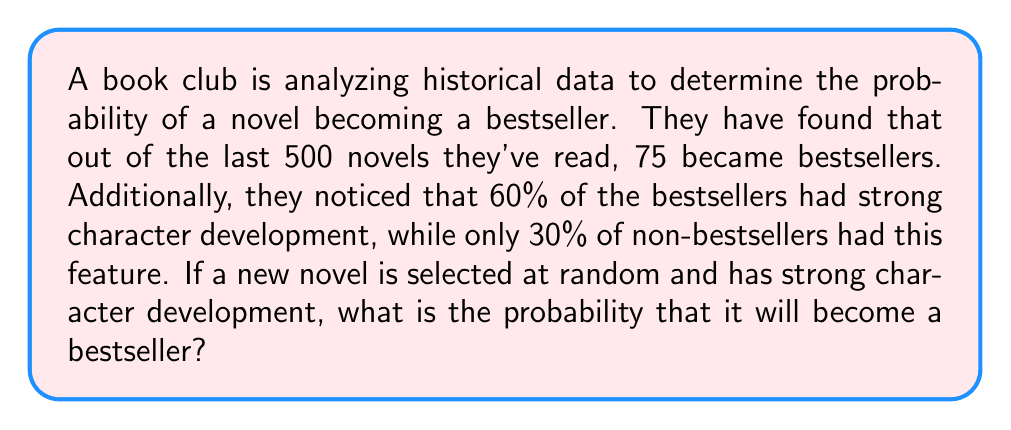Could you help me with this problem? Let's approach this problem using Bayes' Theorem. We'll define the following events:

B: The book becomes a bestseller
C: The book has strong character development

We need to find P(B|C), which is the probability that a book becomes a bestseller given that it has strong character development.

Bayes' Theorem states:

$$ P(B|C) = \frac{P(C|B) \cdot P(B)}{P(C)} $$

From the given information:

1. P(B) = 75/500 = 0.15 (probability of a book becoming a bestseller)
2. P(C|B) = 0.60 (probability of strong character development given the book is a bestseller)
3. P(C) = P(C|B) * P(B) + P(C|not B) * P(not B)
   = 0.60 * 0.15 + 0.30 * 0.85 = 0.09 + 0.255 = 0.345

Now we can apply Bayes' Theorem:

$$ P(B|C) = \frac{0.60 \cdot 0.15}{0.345} = \frac{0.09}{0.345} \approx 0.2609 $$

Therefore, the probability that a book with strong character development will become a bestseller is approximately 0.2609 or 26.09%.
Answer: 0.2609 or 26.09% 